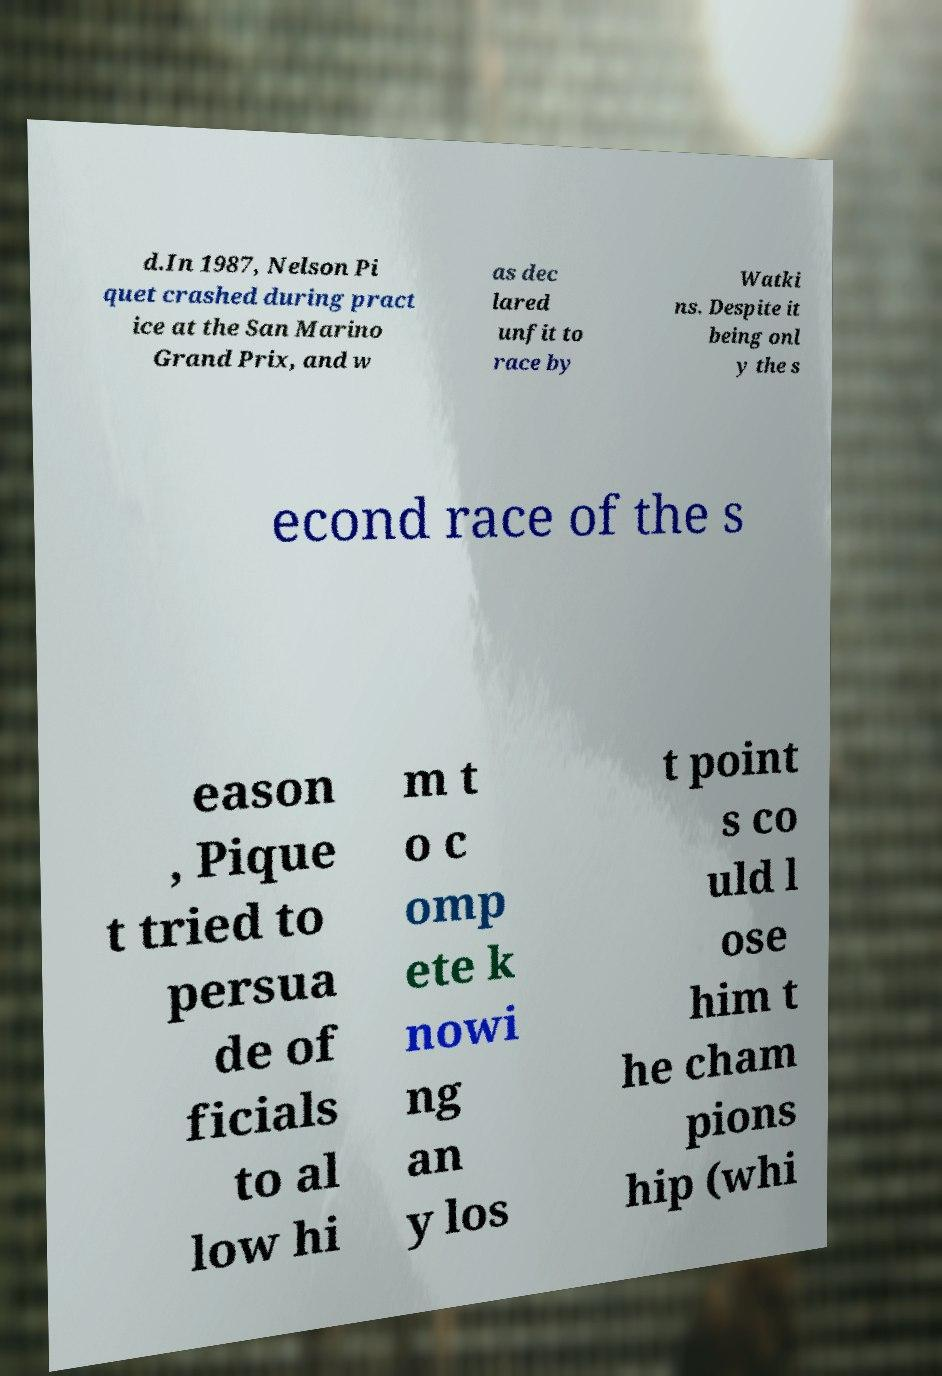For documentation purposes, I need the text within this image transcribed. Could you provide that? d.In 1987, Nelson Pi quet crashed during pract ice at the San Marino Grand Prix, and w as dec lared unfit to race by Watki ns. Despite it being onl y the s econd race of the s eason , Pique t tried to persua de of ficials to al low hi m t o c omp ete k nowi ng an y los t point s co uld l ose him t he cham pions hip (whi 